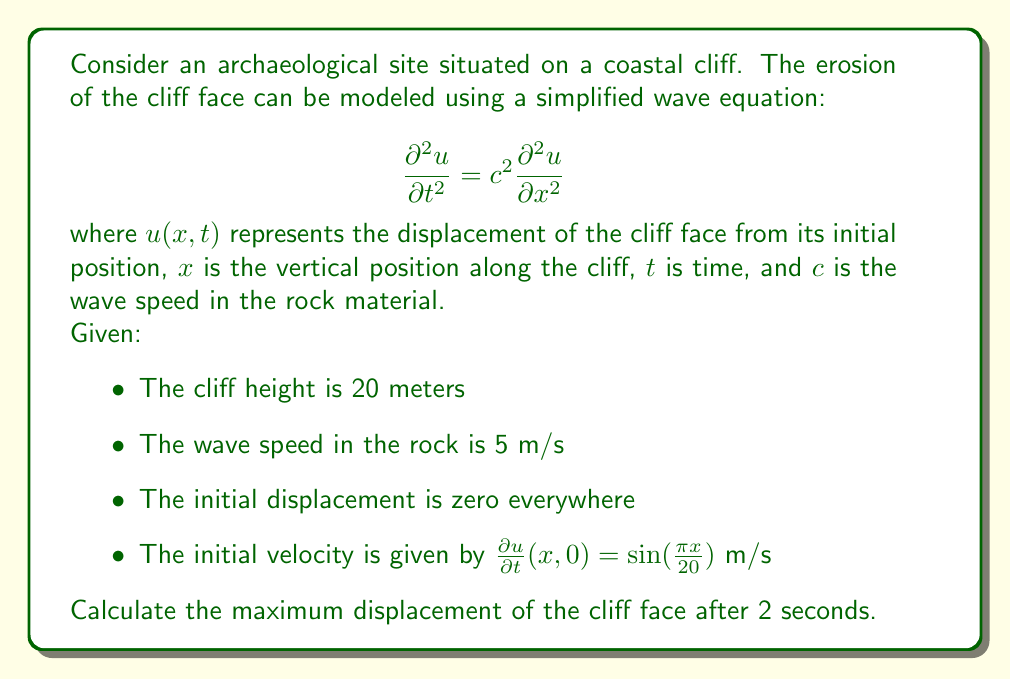Teach me how to tackle this problem. To solve this problem, we need to use the general solution of the wave equation, which is given by d'Alembert's formula:

$$u(x,t) = f(x-ct) + g(x+ct)$$

where $f$ and $g$ are determined by the initial conditions.

Given the initial conditions:
1. $u(x,0) = 0$ (initial displacement is zero)
2. $\frac{\partial u}{\partial t}(x,0) = \sin(\frac{\pi x}{20})$ (initial velocity)

We can determine that:

$$f'(x) = g'(x) = \frac{1}{2c}\sin(\frac{\pi x}{20})$$

Integrating this, we get:

$$f(x) = g(x) = -\frac{10}{\pi c}\cos(\frac{\pi x}{20}) + K$$

where $K$ is a constant. Since $u(x,0) = f(x) + g(x) = 0$, we can determine that $K = \frac{10}{\pi c}$.

Therefore, the solution is:

$$u(x,t) = \frac{10}{\pi c}\left[\cos(\frac{\pi(x-ct)}{20}) + \cos(\frac{\pi(x+ct)}{20}) - 2\right]$$

Substituting the given values ($c = 5$ m/s, $t = 2$ s), we get:

$$u(x,2) = \frac{2}{\pi}\left[\cos(\frac{\pi(x-10)}{20}) + \cos(\frac{\pi(x+10)}{20}) - 2\right]$$

To find the maximum displacement, we need to find the maximum absolute value of this function for $0 \leq x \leq 20$.

The maximum occurs when both cosine terms are at their peak (1) simultaneously, which happens at $x = 10$ m:

$$u(10,2) = \frac{2}{\pi}\left[\cos(\frac{\pi(10-10)}{20}) + \cos(\frac{\pi(10+10)}{20}) - 2\right] = \frac{2}{\pi}[1 + 1 - 2] = 0$$

The minimum occurs when both cosine terms are at their minimum (-1) simultaneously, which happens at $x = 0$ m and $x = 20$ m:

$$u(0,2) = u(20,2) = \frac{2}{\pi}\left[\cos(\frac{\pi(-10)}{20}) + \cos(\frac{\pi(10)}{20}) - 2\right] = \frac{2}{\pi}[-1 - 1 - 2] = -\frac{8}{\pi}$$

Therefore, the maximum displacement is the absolute value of the minimum displacement.
Answer: The maximum displacement of the cliff face after 2 seconds is $\frac{8}{\pi} \approx 2.55$ meters. 